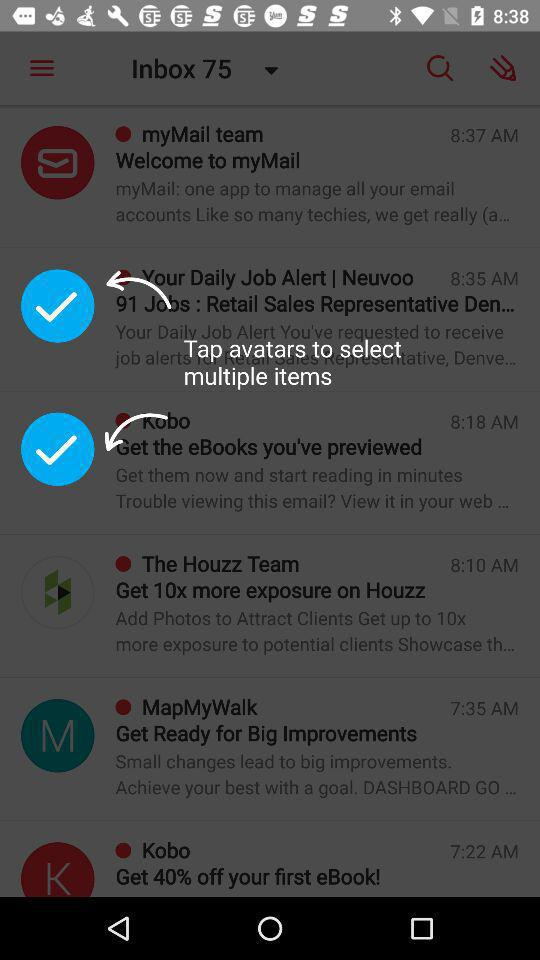How many emails are unread? There are 75 unread emails. 